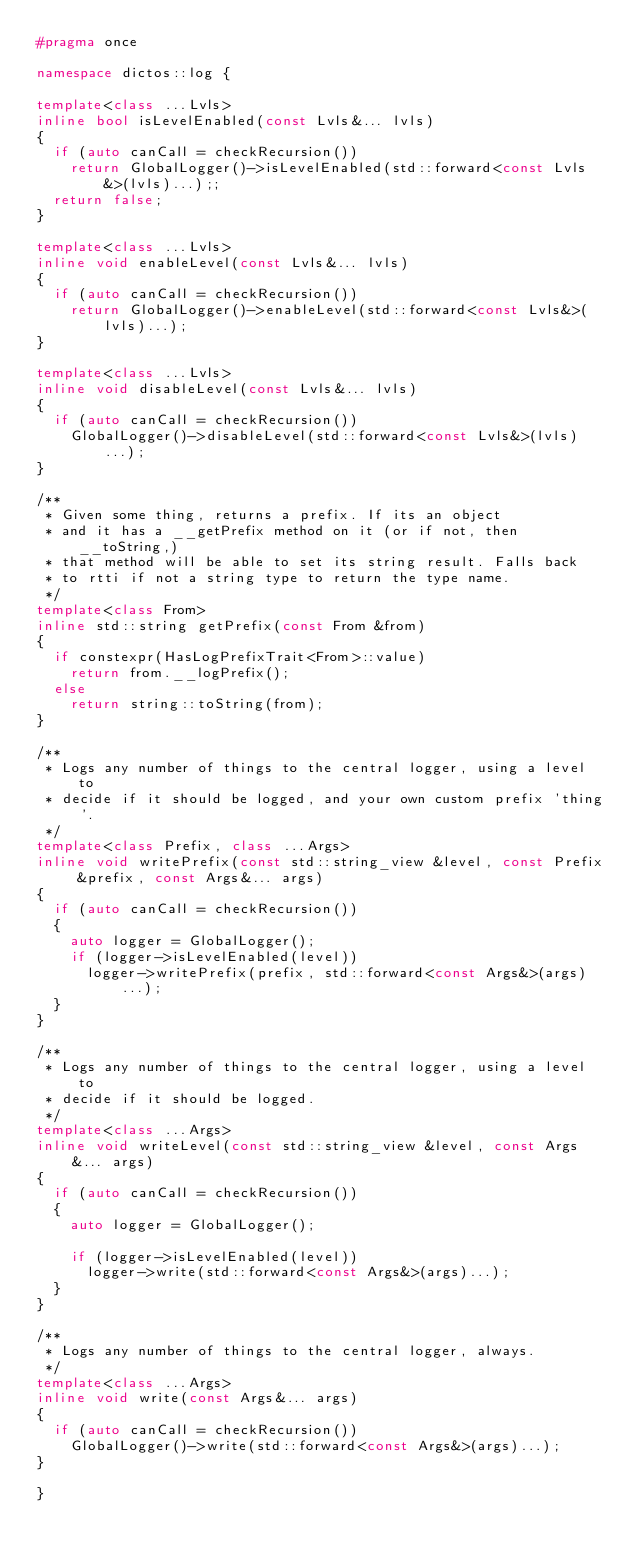<code> <loc_0><loc_0><loc_500><loc_500><_C++_>#pragma once

namespace dictos::log {

template<class ...Lvls>
inline bool isLevelEnabled(const Lvls&... lvls)
{
	if (auto canCall = checkRecursion())
		return GlobalLogger()->isLevelEnabled(std::forward<const Lvls&>(lvls)...);;
	return false;
}

template<class ...Lvls>
inline void enableLevel(const Lvls&... lvls)
{
	if (auto canCall = checkRecursion())
		return GlobalLogger()->enableLevel(std::forward<const Lvls&>(lvls)...);
}

template<class ...Lvls>
inline void disableLevel(const Lvls&... lvls)
{
	if (auto canCall = checkRecursion())
		GlobalLogger()->disableLevel(std::forward<const Lvls&>(lvls)...);
}

/**
 * Given some thing, returns a prefix. If its an object
 * and it has a __getPrefix method on it (or if not, then __toString,)
 * that method will be able to set its string result. Falls back
 * to rtti if not a string type to return the type name.
 */
template<class From>
inline std::string getPrefix(const From &from)
{
	if constexpr(HasLogPrefixTrait<From>::value)
		return from.__logPrefix();
	else
		return string::toString(from);
}

/**
 * Logs any number of things to the central logger, using a level to
 * decide if it should be logged, and your own custom prefix 'thing'.
 */
template<class Prefix, class ...Args>
inline void writePrefix(const std::string_view &level, const Prefix &prefix, const Args&... args)
{
	if (auto canCall = checkRecursion())
	{
		auto logger = GlobalLogger();
		if (logger->isLevelEnabled(level))
			logger->writePrefix(prefix, std::forward<const Args&>(args)...);
	}
}

/**
 * Logs any number of things to the central logger, using a level to
 * decide if it should be logged.
 */
template<class ...Args>
inline void writeLevel(const std::string_view &level, const Args&... args)
{
	if (auto canCall = checkRecursion())
	{
		auto logger = GlobalLogger();

		if (logger->isLevelEnabled(level))
			logger->write(std::forward<const Args&>(args)...);
	}
}

/**
 * Logs any number of things to the central logger, always.
 */
template<class ...Args>
inline void write(const Args&... args)
{
	if (auto canCall = checkRecursion())
		GlobalLogger()->write(std::forward<const Args&>(args)...);
}

}
</code> 